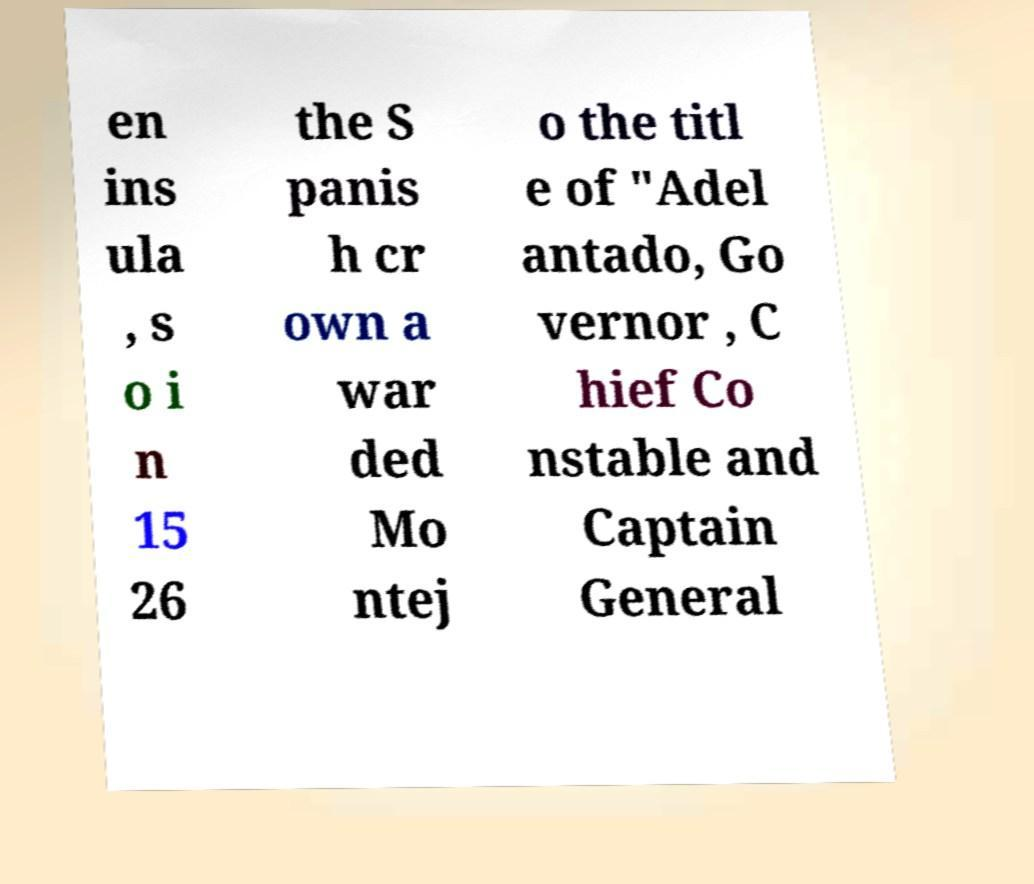Please identify and transcribe the text found in this image. en ins ula , s o i n 15 26 the S panis h cr own a war ded Mo ntej o the titl e of "Adel antado, Go vernor , C hief Co nstable and Captain General 